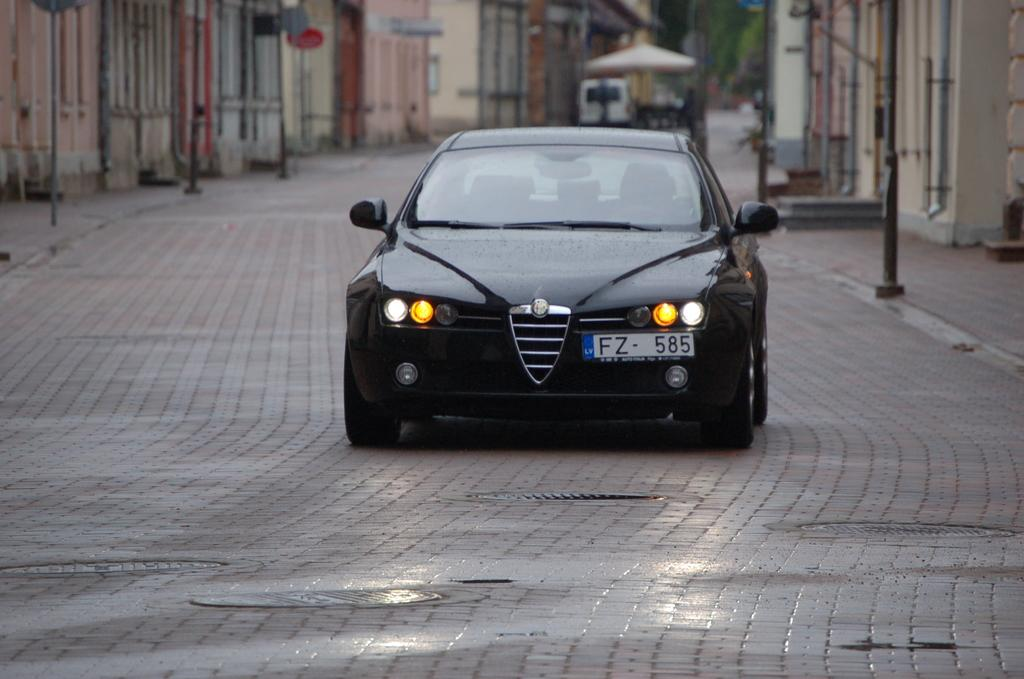What types of objects are on the ground in the image? There are vehicles on the ground in the image. What structures can be seen in the image? There are buildings in the image. What vertical objects are present in the image? There are poles in the image. What flat objects are present in the image? There are boards in the image. What is used for protection from the sun in the image? There is an umbrella in the image. What type of soap is being used to clean the vehicles in the image? There is no soap present in the image, and the vehicles are not being cleaned. What type of calendar is hanging on the wall in the image? There is no calendar present in the image. 